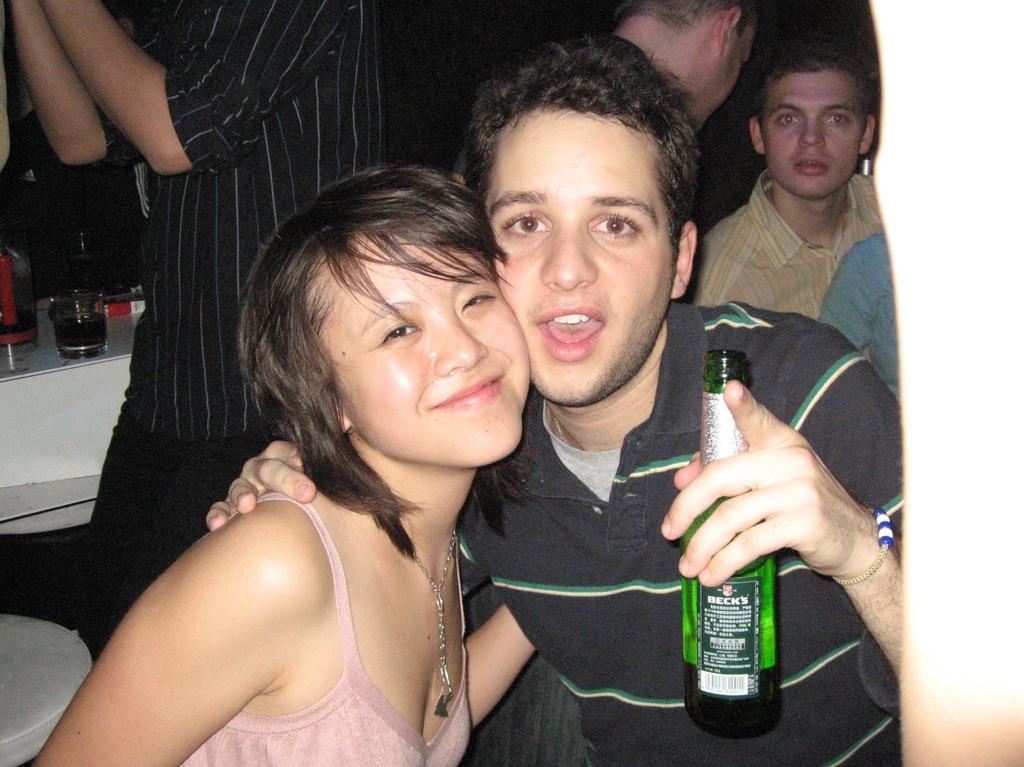Could you give a brief overview of what you see in this image? In the center we can see two persons the lady she is laughing which we can see on her face. And man is holding wine bottle. Coming to the background we can see some more persons were sitting. Here we can see some table on table we can see some objects. 